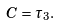Convert formula to latex. <formula><loc_0><loc_0><loc_500><loc_500>C = \tau _ { 3 } .</formula> 